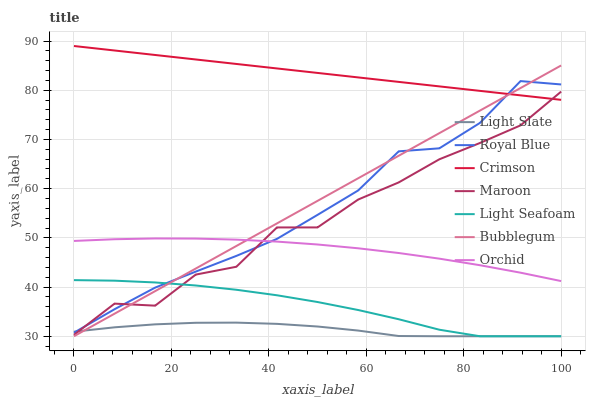Does Bubblegum have the minimum area under the curve?
Answer yes or no. No. Does Bubblegum have the maximum area under the curve?
Answer yes or no. No. Is Bubblegum the smoothest?
Answer yes or no. No. Is Bubblegum the roughest?
Answer yes or no. No. Does Royal Blue have the lowest value?
Answer yes or no. No. Does Bubblegum have the highest value?
Answer yes or no. No. Is Light Slate less than Crimson?
Answer yes or no. Yes. Is Crimson greater than Light Slate?
Answer yes or no. Yes. Does Light Slate intersect Crimson?
Answer yes or no. No. 